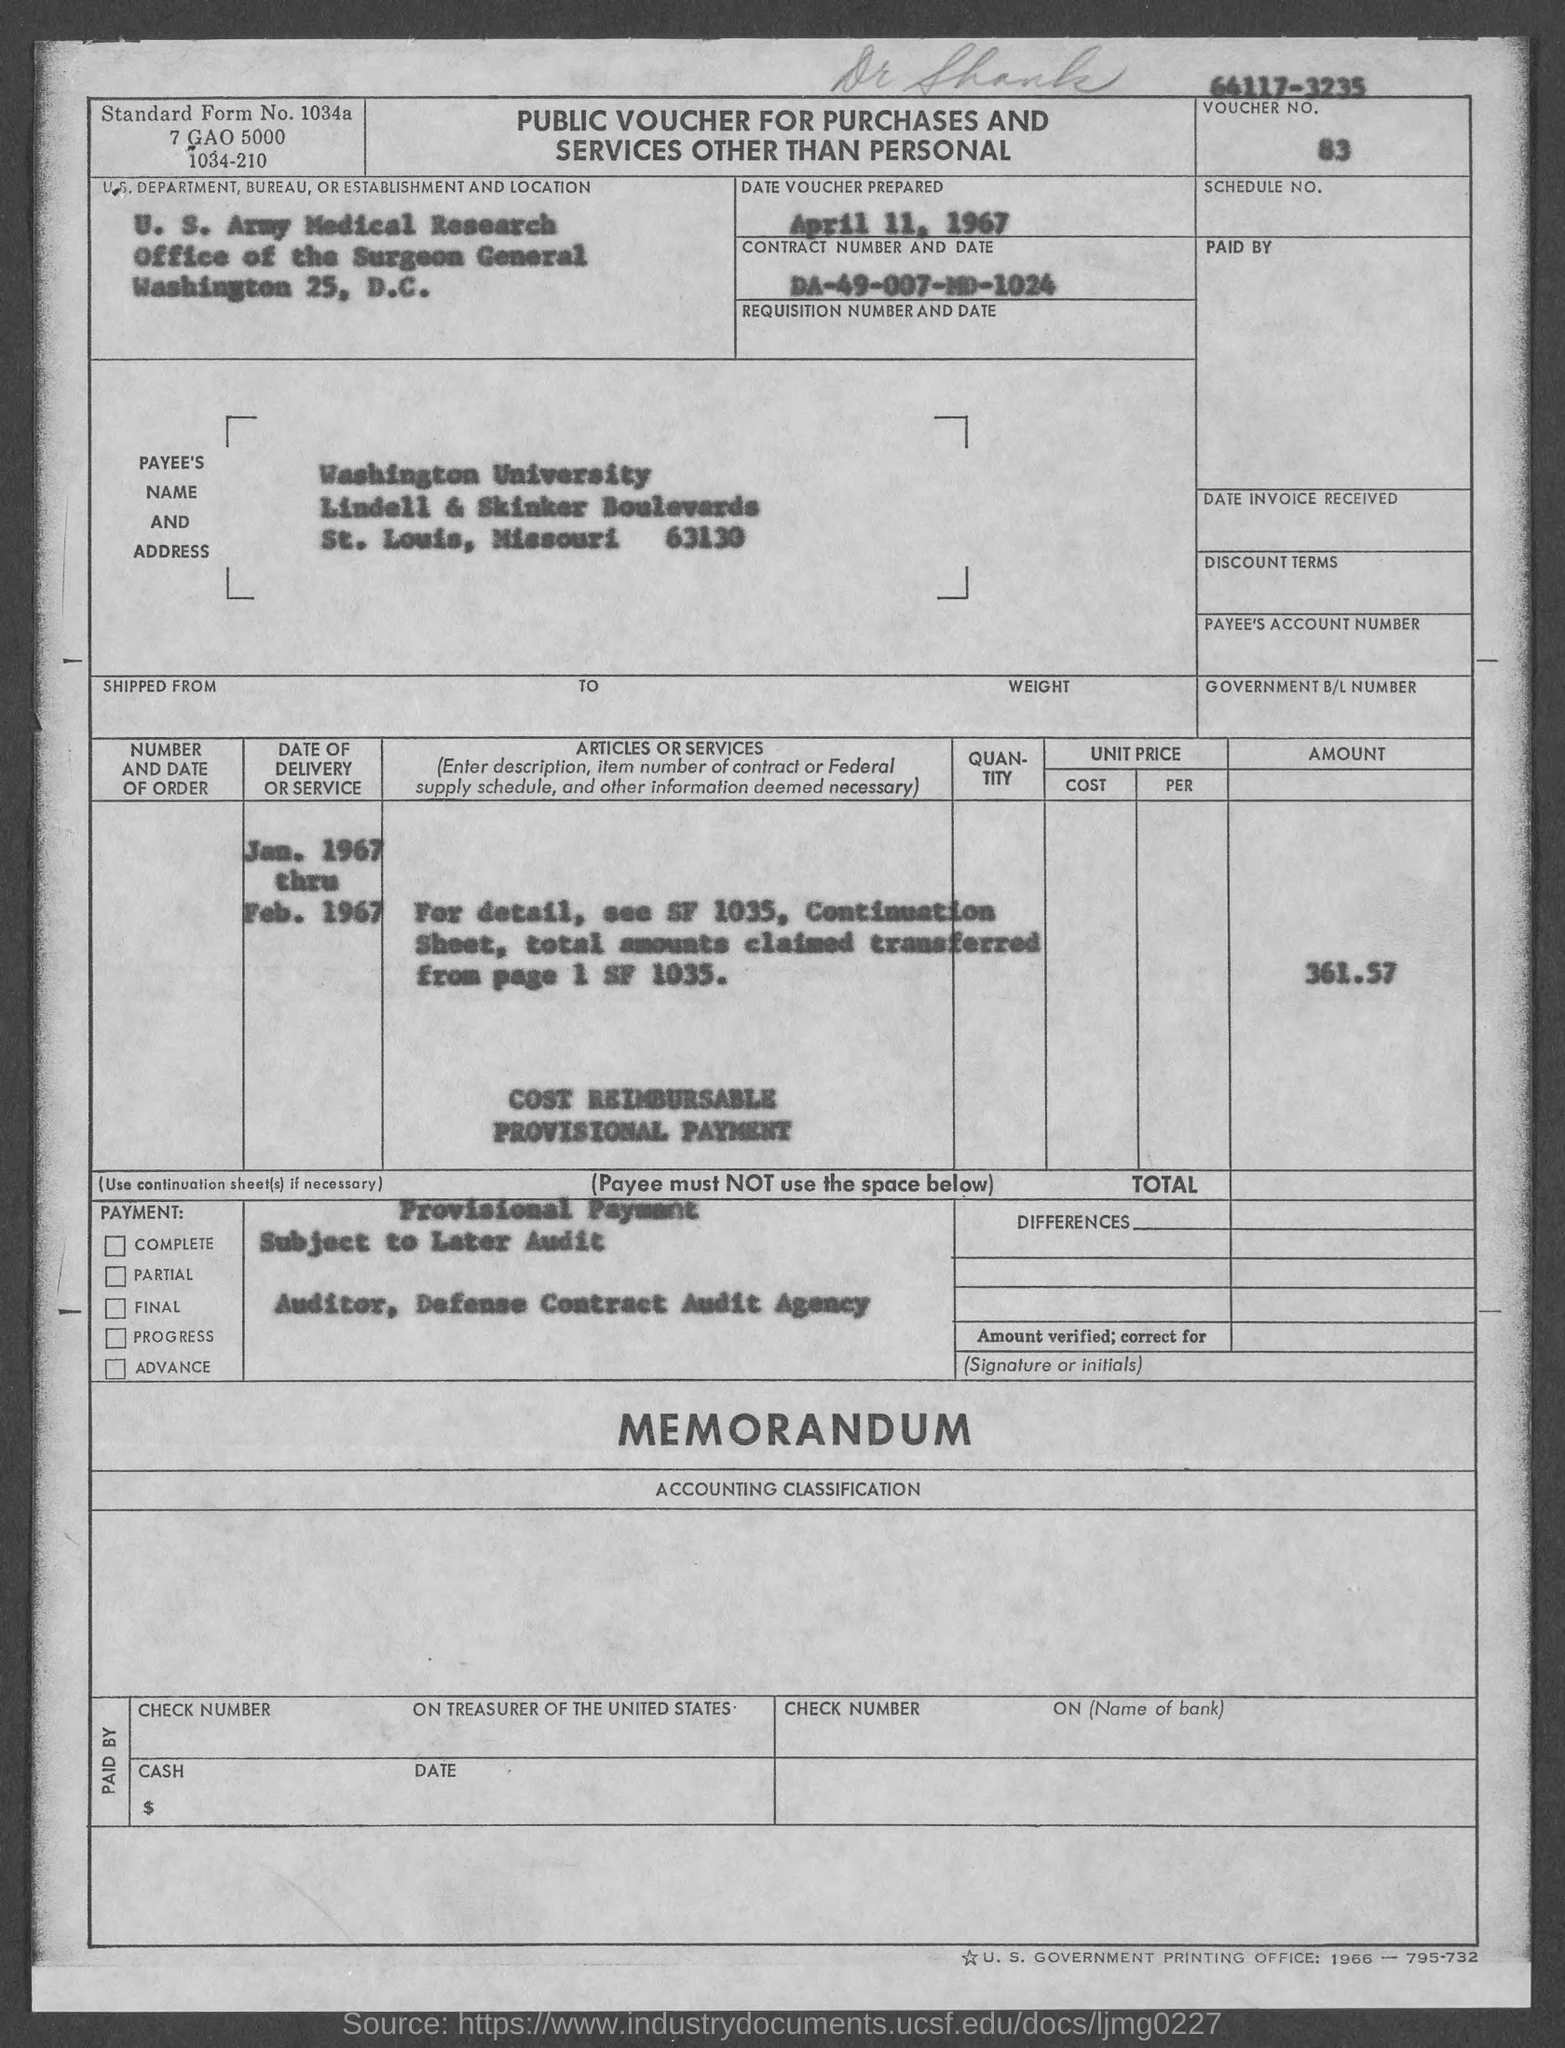What is the voucher number mentioned in the given form ?
Your answer should be compact. 83. What is the date of voucher prepared s mentioned in the given form ?
Offer a very short reply. April 11, 1967. What is the contract no. mentioned in the given form ?
Offer a very short reply. DA-49-007-MD-1024. What is the amount mentioned in the given form ?
Make the answer very short. 361.57. 